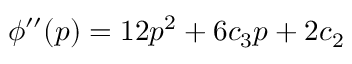Convert formula to latex. <formula><loc_0><loc_0><loc_500><loc_500>\phi ^ { \prime \prime } ( p ) = 1 2 p ^ { 2 } + 6 c _ { 3 } p + 2 c _ { 2 }</formula> 